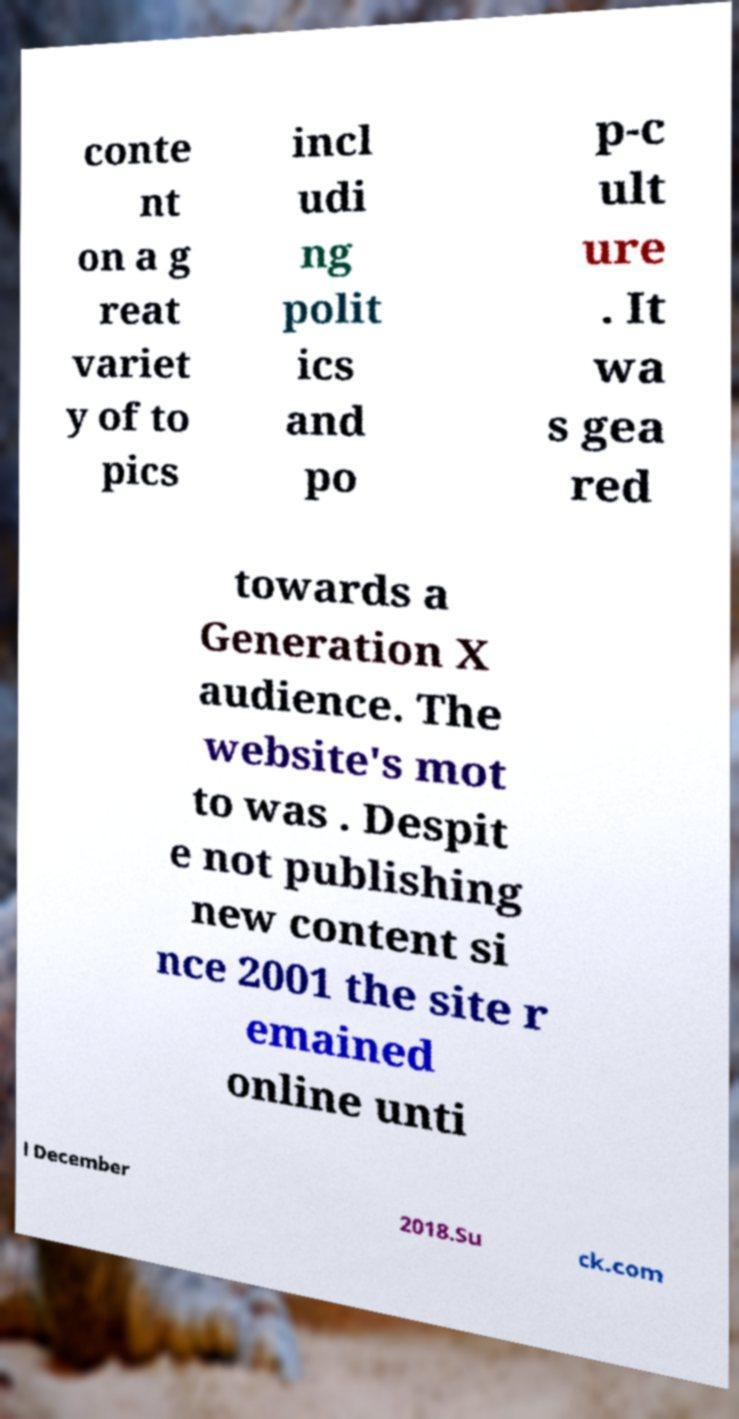Please identify and transcribe the text found in this image. conte nt on a g reat variet y of to pics incl udi ng polit ics and po p-c ult ure . It wa s gea red towards a Generation X audience. The website's mot to was . Despit e not publishing new content si nce 2001 the site r emained online unti l December 2018.Su ck.com 